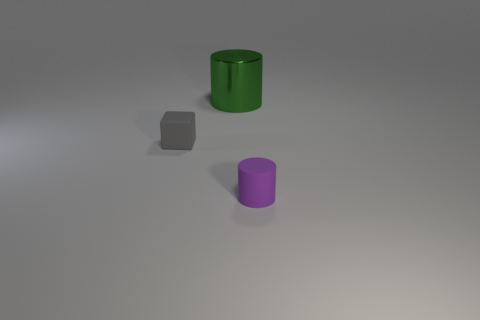Add 3 gray things. How many objects exist? 6 Subtract all blocks. How many objects are left? 2 Subtract 0 cyan spheres. How many objects are left? 3 Subtract all small gray things. Subtract all gray objects. How many objects are left? 1 Add 1 purple matte things. How many purple matte things are left? 2 Add 3 red metallic objects. How many red metallic objects exist? 3 